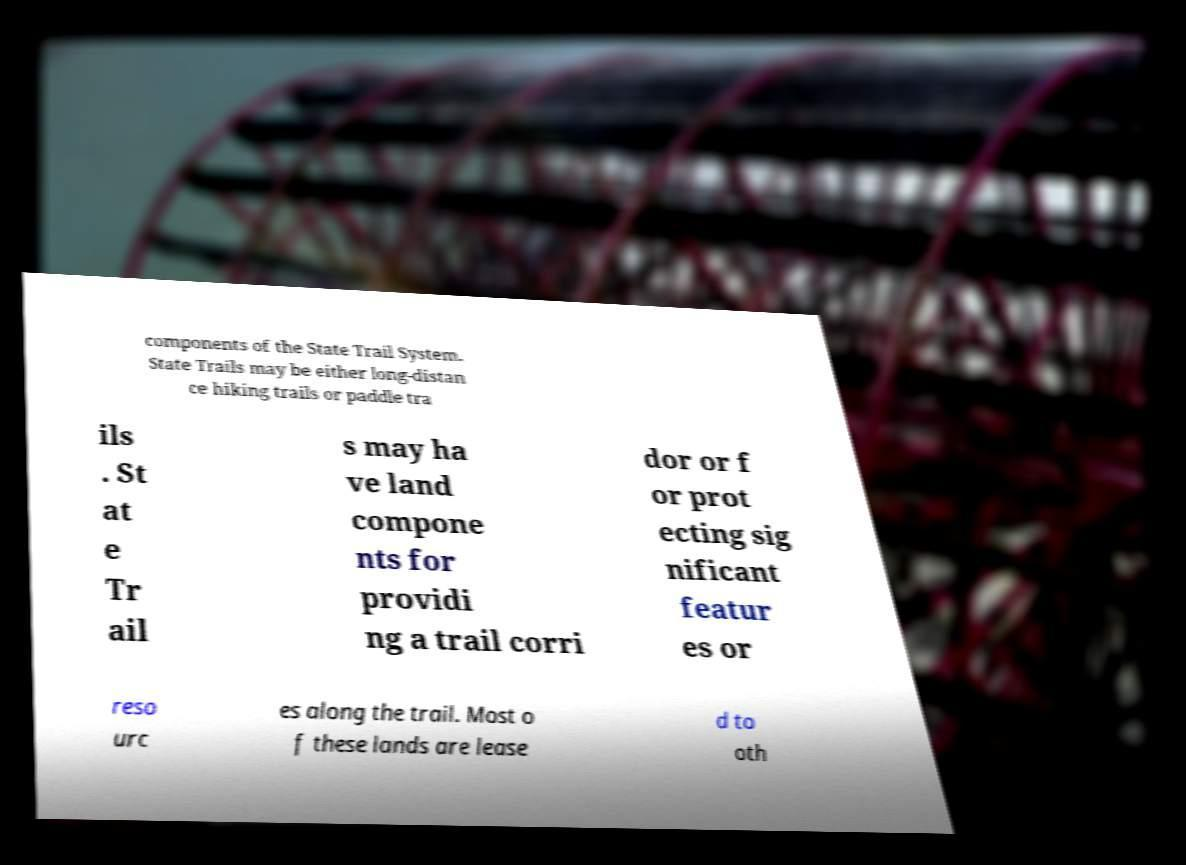I need the written content from this picture converted into text. Can you do that? components of the State Trail System. State Trails may be either long-distan ce hiking trails or paddle tra ils . St at e Tr ail s may ha ve land compone nts for providi ng a trail corri dor or f or prot ecting sig nificant featur es or reso urc es along the trail. Most o f these lands are lease d to oth 